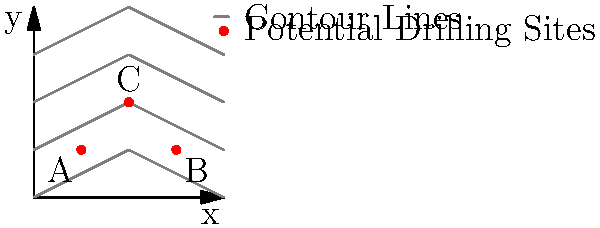Based on the topographical map shown, which potential drilling location (A, B, or C) would likely be the safest in terms of geological stability and environmental impact? To determine the safest drilling location, we need to consider the following factors:

1. Elevation: Higher elevations are generally more stable and less prone to flooding.
2. Slope: Gentler slopes are safer for drilling operations and less susceptible to landslides.
3. Proximity to contour lines: Areas with widely spaced contour lines indicate gentler slopes.

Analyzing each location:

A (1,1):
- Located at a lower elevation
- Closer spacing between contour lines indicates steeper slope
- Higher risk of flooding and landslides

B (3,1):
- Located at a lower elevation
- Wider spacing between contour lines indicates gentler slope
- Still at risk of flooding due to low elevation

C (2,2):
- Located at a higher elevation
- Moderate spacing between contour lines indicates a balanced slope
- Reduced risk of flooding due to higher elevation
- Better overall stability compared to A and B

Considering these factors, location C (2,2) appears to be the safest option for drilling. Its higher elevation provides protection against flooding, while the moderate slope offers a good balance between stability and accessibility for drilling operations.
Answer: C (2,2) 